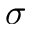Convert formula to latex. <formula><loc_0><loc_0><loc_500><loc_500>\sigma</formula> 